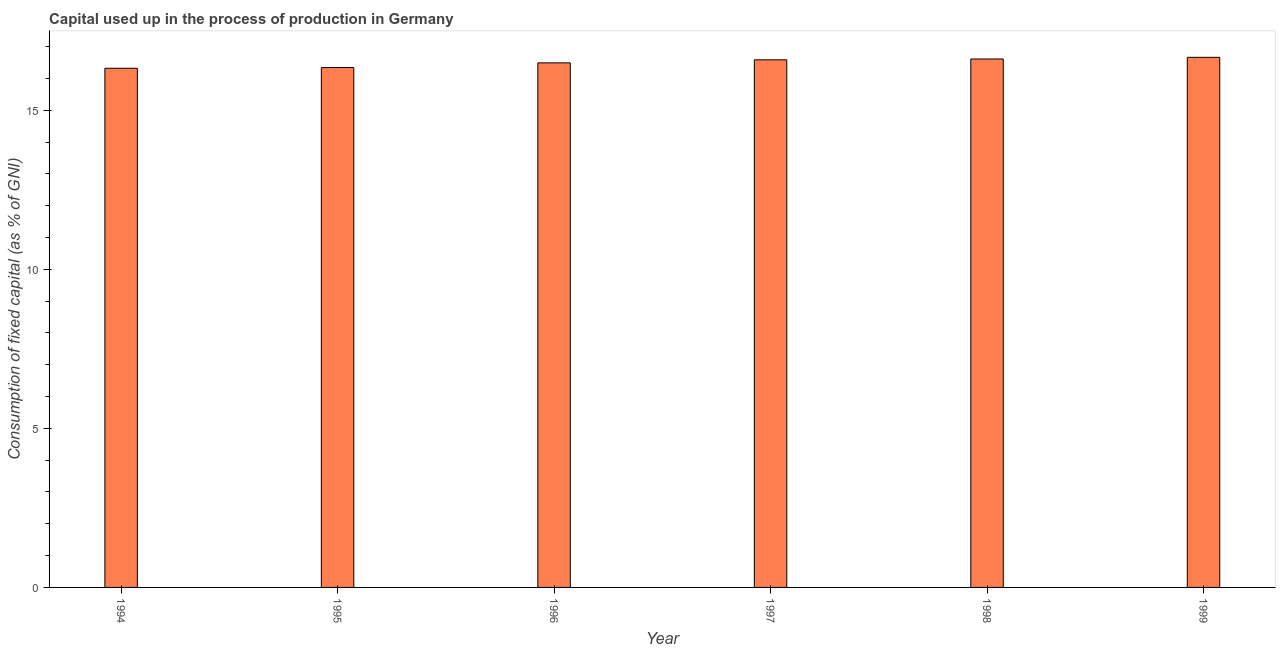Does the graph contain grids?
Keep it short and to the point. No. What is the title of the graph?
Your answer should be compact. Capital used up in the process of production in Germany. What is the label or title of the Y-axis?
Keep it short and to the point. Consumption of fixed capital (as % of GNI). What is the consumption of fixed capital in 1998?
Make the answer very short. 16.61. Across all years, what is the maximum consumption of fixed capital?
Offer a terse response. 16.66. Across all years, what is the minimum consumption of fixed capital?
Your answer should be very brief. 16.32. What is the sum of the consumption of fixed capital?
Offer a very short reply. 99.01. What is the difference between the consumption of fixed capital in 1996 and 1997?
Keep it short and to the point. -0.1. What is the average consumption of fixed capital per year?
Make the answer very short. 16.5. What is the median consumption of fixed capital?
Ensure brevity in your answer.  16.54. Do a majority of the years between 1997 and 1996 (inclusive) have consumption of fixed capital greater than 3 %?
Offer a very short reply. No. What is the ratio of the consumption of fixed capital in 1994 to that in 1996?
Keep it short and to the point. 0.99. Is the consumption of fixed capital in 1994 less than that in 1998?
Give a very brief answer. Yes. Is the difference between the consumption of fixed capital in 1994 and 1998 greater than the difference between any two years?
Provide a short and direct response. No. What is the difference between the highest and the second highest consumption of fixed capital?
Ensure brevity in your answer.  0.05. Is the sum of the consumption of fixed capital in 1998 and 1999 greater than the maximum consumption of fixed capital across all years?
Make the answer very short. Yes. What is the difference between the highest and the lowest consumption of fixed capital?
Your response must be concise. 0.34. In how many years, is the consumption of fixed capital greater than the average consumption of fixed capital taken over all years?
Make the answer very short. 3. Are all the bars in the graph horizontal?
Make the answer very short. No. How many years are there in the graph?
Offer a very short reply. 6. What is the difference between two consecutive major ticks on the Y-axis?
Provide a short and direct response. 5. Are the values on the major ticks of Y-axis written in scientific E-notation?
Offer a terse response. No. What is the Consumption of fixed capital (as % of GNI) of 1994?
Provide a short and direct response. 16.32. What is the Consumption of fixed capital (as % of GNI) in 1995?
Ensure brevity in your answer.  16.34. What is the Consumption of fixed capital (as % of GNI) of 1996?
Your answer should be very brief. 16.49. What is the Consumption of fixed capital (as % of GNI) of 1997?
Keep it short and to the point. 16.58. What is the Consumption of fixed capital (as % of GNI) in 1998?
Your response must be concise. 16.61. What is the Consumption of fixed capital (as % of GNI) in 1999?
Provide a short and direct response. 16.66. What is the difference between the Consumption of fixed capital (as % of GNI) in 1994 and 1995?
Offer a terse response. -0.02. What is the difference between the Consumption of fixed capital (as % of GNI) in 1994 and 1996?
Your answer should be very brief. -0.17. What is the difference between the Consumption of fixed capital (as % of GNI) in 1994 and 1997?
Make the answer very short. -0.27. What is the difference between the Consumption of fixed capital (as % of GNI) in 1994 and 1998?
Provide a succinct answer. -0.29. What is the difference between the Consumption of fixed capital (as % of GNI) in 1994 and 1999?
Offer a very short reply. -0.34. What is the difference between the Consumption of fixed capital (as % of GNI) in 1995 and 1996?
Keep it short and to the point. -0.15. What is the difference between the Consumption of fixed capital (as % of GNI) in 1995 and 1997?
Make the answer very short. -0.24. What is the difference between the Consumption of fixed capital (as % of GNI) in 1995 and 1998?
Give a very brief answer. -0.27. What is the difference between the Consumption of fixed capital (as % of GNI) in 1995 and 1999?
Your answer should be very brief. -0.32. What is the difference between the Consumption of fixed capital (as % of GNI) in 1996 and 1997?
Offer a very short reply. -0.1. What is the difference between the Consumption of fixed capital (as % of GNI) in 1996 and 1998?
Your response must be concise. -0.12. What is the difference between the Consumption of fixed capital (as % of GNI) in 1996 and 1999?
Provide a succinct answer. -0.17. What is the difference between the Consumption of fixed capital (as % of GNI) in 1997 and 1998?
Your answer should be compact. -0.03. What is the difference between the Consumption of fixed capital (as % of GNI) in 1997 and 1999?
Provide a short and direct response. -0.08. What is the difference between the Consumption of fixed capital (as % of GNI) in 1998 and 1999?
Offer a terse response. -0.05. What is the ratio of the Consumption of fixed capital (as % of GNI) in 1994 to that in 1996?
Your answer should be very brief. 0.99. What is the ratio of the Consumption of fixed capital (as % of GNI) in 1994 to that in 1997?
Offer a terse response. 0.98. What is the ratio of the Consumption of fixed capital (as % of GNI) in 1994 to that in 1998?
Your answer should be very brief. 0.98. What is the ratio of the Consumption of fixed capital (as % of GNI) in 1994 to that in 1999?
Your answer should be very brief. 0.98. What is the ratio of the Consumption of fixed capital (as % of GNI) in 1995 to that in 1996?
Ensure brevity in your answer.  0.99. What is the ratio of the Consumption of fixed capital (as % of GNI) in 1995 to that in 1999?
Your answer should be compact. 0.98. What is the ratio of the Consumption of fixed capital (as % of GNI) in 1996 to that in 1997?
Offer a very short reply. 0.99. What is the ratio of the Consumption of fixed capital (as % of GNI) in 1996 to that in 1998?
Offer a very short reply. 0.99. What is the ratio of the Consumption of fixed capital (as % of GNI) in 1996 to that in 1999?
Your answer should be compact. 0.99. What is the ratio of the Consumption of fixed capital (as % of GNI) in 1997 to that in 1999?
Offer a terse response. 0.99. What is the ratio of the Consumption of fixed capital (as % of GNI) in 1998 to that in 1999?
Your answer should be very brief. 1. 